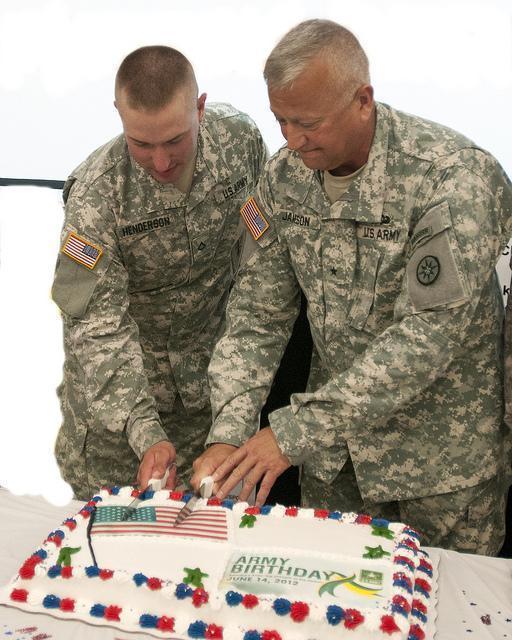How many people are there?
Give a very brief answer. 2. How many yellow bikes are there?
Give a very brief answer. 0. 